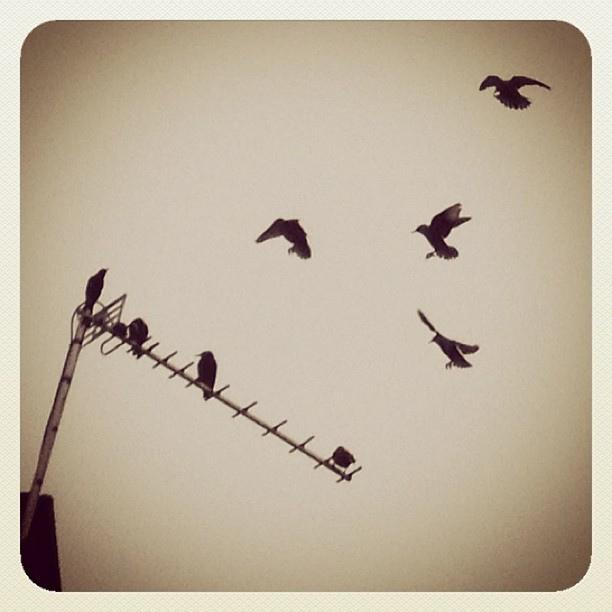Can what the birds are sitting on be moved?
Concise answer only. Yes. What are the birds sitting on?
Answer briefly. Antenna. How many birds are flying?
Be succinct. 4. 